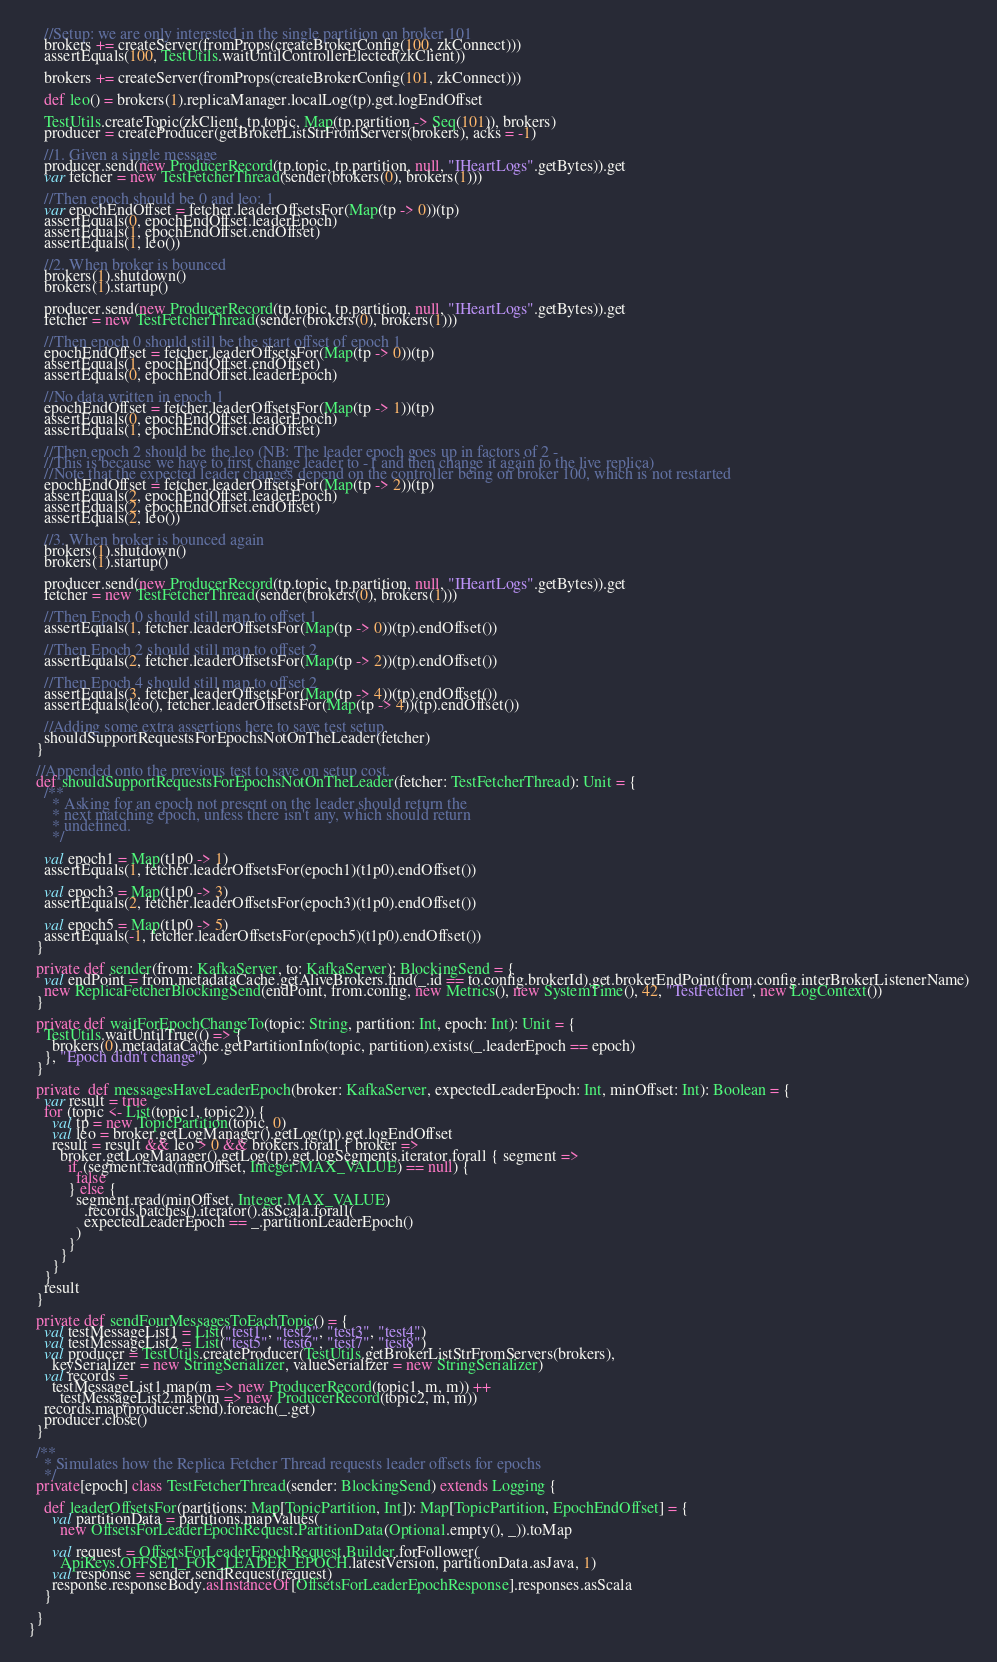Convert code to text. <code><loc_0><loc_0><loc_500><loc_500><_Scala_>    //Setup: we are only interested in the single partition on broker 101
    brokers += createServer(fromProps(createBrokerConfig(100, zkConnect)))
    assertEquals(100, TestUtils.waitUntilControllerElected(zkClient))

    brokers += createServer(fromProps(createBrokerConfig(101, zkConnect)))

    def leo() = brokers(1).replicaManager.localLog(tp).get.logEndOffset

    TestUtils.createTopic(zkClient, tp.topic, Map(tp.partition -> Seq(101)), brokers)
    producer = createProducer(getBrokerListStrFromServers(brokers), acks = -1)

    //1. Given a single message
    producer.send(new ProducerRecord(tp.topic, tp.partition, null, "IHeartLogs".getBytes)).get
    var fetcher = new TestFetcherThread(sender(brokers(0), brokers(1)))

    //Then epoch should be 0 and leo: 1
    var epochEndOffset = fetcher.leaderOffsetsFor(Map(tp -> 0))(tp)
    assertEquals(0, epochEndOffset.leaderEpoch)
    assertEquals(1, epochEndOffset.endOffset)
    assertEquals(1, leo())

    //2. When broker is bounced
    brokers(1).shutdown()
    brokers(1).startup()

    producer.send(new ProducerRecord(tp.topic, tp.partition, null, "IHeartLogs".getBytes)).get
    fetcher = new TestFetcherThread(sender(brokers(0), brokers(1)))

    //Then epoch 0 should still be the start offset of epoch 1
    epochEndOffset = fetcher.leaderOffsetsFor(Map(tp -> 0))(tp)
    assertEquals(1, epochEndOffset.endOffset)
    assertEquals(0, epochEndOffset.leaderEpoch)

    //No data written in epoch 1
    epochEndOffset = fetcher.leaderOffsetsFor(Map(tp -> 1))(tp)
    assertEquals(0, epochEndOffset.leaderEpoch)
    assertEquals(1, epochEndOffset.endOffset)

    //Then epoch 2 should be the leo (NB: The leader epoch goes up in factors of 2 -
    //This is because we have to first change leader to -1 and then change it again to the live replica)
    //Note that the expected leader changes depend on the controller being on broker 100, which is not restarted
    epochEndOffset = fetcher.leaderOffsetsFor(Map(tp -> 2))(tp)
    assertEquals(2, epochEndOffset.leaderEpoch)
    assertEquals(2, epochEndOffset.endOffset)
    assertEquals(2, leo())

    //3. When broker is bounced again
    brokers(1).shutdown()
    brokers(1).startup()

    producer.send(new ProducerRecord(tp.topic, tp.partition, null, "IHeartLogs".getBytes)).get
    fetcher = new TestFetcherThread(sender(brokers(0), brokers(1)))

    //Then Epoch 0 should still map to offset 1
    assertEquals(1, fetcher.leaderOffsetsFor(Map(tp -> 0))(tp).endOffset())

    //Then Epoch 2 should still map to offset 2
    assertEquals(2, fetcher.leaderOffsetsFor(Map(tp -> 2))(tp).endOffset())

    //Then Epoch 4 should still map to offset 2
    assertEquals(3, fetcher.leaderOffsetsFor(Map(tp -> 4))(tp).endOffset())
    assertEquals(leo(), fetcher.leaderOffsetsFor(Map(tp -> 4))(tp).endOffset())

    //Adding some extra assertions here to save test setup.
    shouldSupportRequestsForEpochsNotOnTheLeader(fetcher)
  }

  //Appended onto the previous test to save on setup cost.
  def shouldSupportRequestsForEpochsNotOnTheLeader(fetcher: TestFetcherThread): Unit = {
    /**
      * Asking for an epoch not present on the leader should return the
      * next matching epoch, unless there isn't any, which should return
      * undefined.
      */

    val epoch1 = Map(t1p0 -> 1)
    assertEquals(1, fetcher.leaderOffsetsFor(epoch1)(t1p0).endOffset())

    val epoch3 = Map(t1p0 -> 3)
    assertEquals(2, fetcher.leaderOffsetsFor(epoch3)(t1p0).endOffset())

    val epoch5 = Map(t1p0 -> 5)
    assertEquals(-1, fetcher.leaderOffsetsFor(epoch5)(t1p0).endOffset())
  }

  private def sender(from: KafkaServer, to: KafkaServer): BlockingSend = {
    val endPoint = from.metadataCache.getAliveBrokers.find(_.id == to.config.brokerId).get.brokerEndPoint(from.config.interBrokerListenerName)
    new ReplicaFetcherBlockingSend(endPoint, from.config, new Metrics(), new SystemTime(), 42, "TestFetcher", new LogContext())
  }

  private def waitForEpochChangeTo(topic: String, partition: Int, epoch: Int): Unit = {
    TestUtils.waitUntilTrue(() => {
      brokers(0).metadataCache.getPartitionInfo(topic, partition).exists(_.leaderEpoch == epoch)
    }, "Epoch didn't change")
  }

  private  def messagesHaveLeaderEpoch(broker: KafkaServer, expectedLeaderEpoch: Int, minOffset: Int): Boolean = {
    var result = true
    for (topic <- List(topic1, topic2)) {
      val tp = new TopicPartition(topic, 0)
      val leo = broker.getLogManager().getLog(tp).get.logEndOffset
      result = result && leo > 0 && brokers.forall { broker =>
        broker.getLogManager().getLog(tp).get.logSegments.iterator.forall { segment =>
          if (segment.read(minOffset, Integer.MAX_VALUE) == null) {
            false
          } else {
            segment.read(minOffset, Integer.MAX_VALUE)
              .records.batches().iterator().asScala.forall(
              expectedLeaderEpoch == _.partitionLeaderEpoch()
            )
          }
        }
      }
    }
    result
  }

  private def sendFourMessagesToEachTopic() = {
    val testMessageList1 = List("test1", "test2", "test3", "test4")
    val testMessageList2 = List("test5", "test6", "test7", "test8")
    val producer = TestUtils.createProducer(TestUtils.getBrokerListStrFromServers(brokers),
      keySerializer = new StringSerializer, valueSerializer = new StringSerializer)
    val records =
      testMessageList1.map(m => new ProducerRecord(topic1, m, m)) ++
        testMessageList2.map(m => new ProducerRecord(topic2, m, m))
    records.map(producer.send).foreach(_.get)
    producer.close()
  }

  /**
    * Simulates how the Replica Fetcher Thread requests leader offsets for epochs
    */
  private[epoch] class TestFetcherThread(sender: BlockingSend) extends Logging {

    def leaderOffsetsFor(partitions: Map[TopicPartition, Int]): Map[TopicPartition, EpochEndOffset] = {
      val partitionData = partitions.mapValues(
        new OffsetsForLeaderEpochRequest.PartitionData(Optional.empty(), _)).toMap

      val request = OffsetsForLeaderEpochRequest.Builder.forFollower(
        ApiKeys.OFFSET_FOR_LEADER_EPOCH.latestVersion, partitionData.asJava, 1)
      val response = sender.sendRequest(request)
      response.responseBody.asInstanceOf[OffsetsForLeaderEpochResponse].responses.asScala
    }

  }
}
</code> 